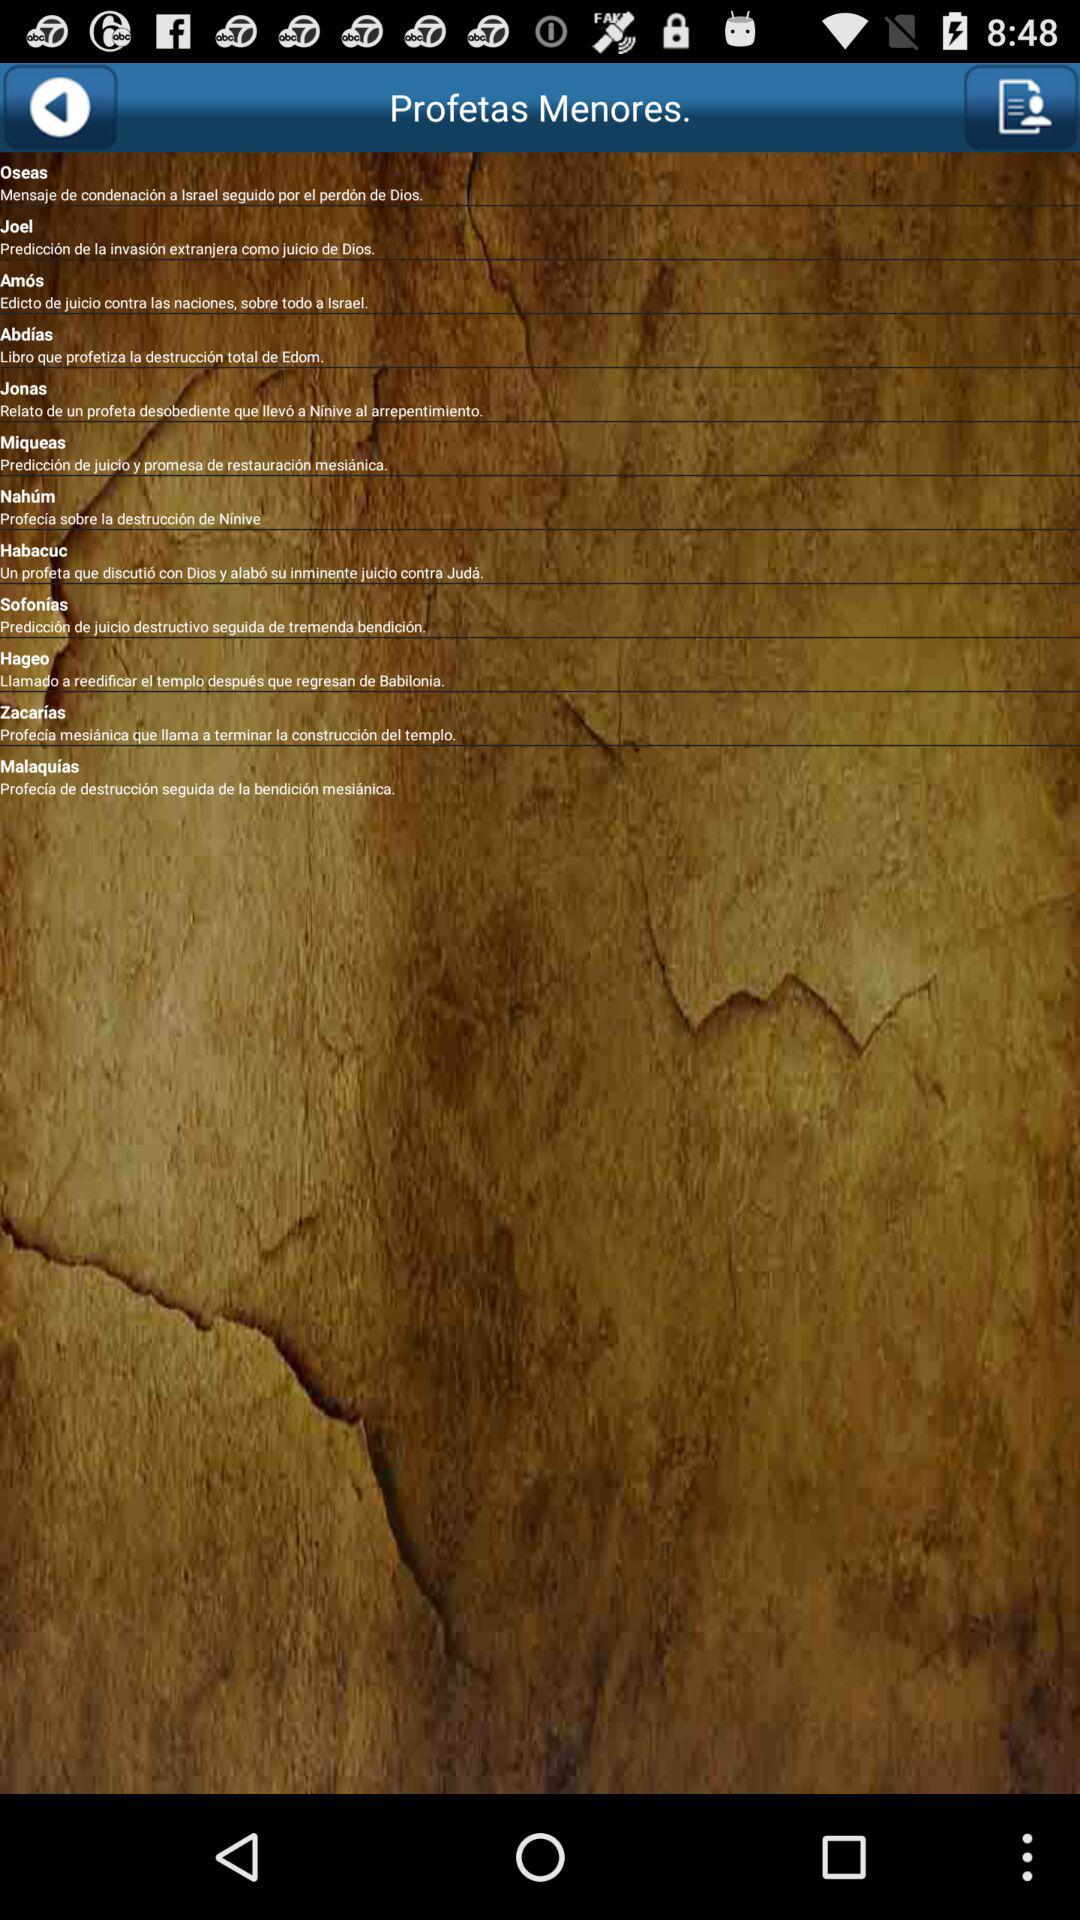How many books are in the Minor Prophets section?
Answer the question using a single word or phrase. 12 